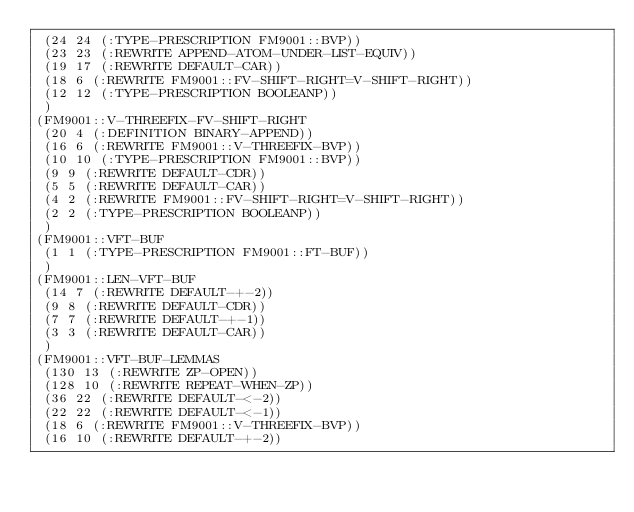Convert code to text. <code><loc_0><loc_0><loc_500><loc_500><_Lisp_> (24 24 (:TYPE-PRESCRIPTION FM9001::BVP))
 (23 23 (:REWRITE APPEND-ATOM-UNDER-LIST-EQUIV))
 (19 17 (:REWRITE DEFAULT-CAR))
 (18 6 (:REWRITE FM9001::FV-SHIFT-RIGHT=V-SHIFT-RIGHT))
 (12 12 (:TYPE-PRESCRIPTION BOOLEANP))
 )
(FM9001::V-THREEFIX-FV-SHIFT-RIGHT
 (20 4 (:DEFINITION BINARY-APPEND))
 (16 6 (:REWRITE FM9001::V-THREEFIX-BVP))
 (10 10 (:TYPE-PRESCRIPTION FM9001::BVP))
 (9 9 (:REWRITE DEFAULT-CDR))
 (5 5 (:REWRITE DEFAULT-CAR))
 (4 2 (:REWRITE FM9001::FV-SHIFT-RIGHT=V-SHIFT-RIGHT))
 (2 2 (:TYPE-PRESCRIPTION BOOLEANP))
 )
(FM9001::VFT-BUF
 (1 1 (:TYPE-PRESCRIPTION FM9001::FT-BUF))
 )
(FM9001::LEN-VFT-BUF
 (14 7 (:REWRITE DEFAULT-+-2))
 (9 8 (:REWRITE DEFAULT-CDR))
 (7 7 (:REWRITE DEFAULT-+-1))
 (3 3 (:REWRITE DEFAULT-CAR))
 )
(FM9001::VFT-BUF-LEMMAS
 (130 13 (:REWRITE ZP-OPEN))
 (128 10 (:REWRITE REPEAT-WHEN-ZP))
 (36 22 (:REWRITE DEFAULT-<-2))
 (22 22 (:REWRITE DEFAULT-<-1))
 (18 6 (:REWRITE FM9001::V-THREEFIX-BVP))
 (16 10 (:REWRITE DEFAULT-+-2))</code> 